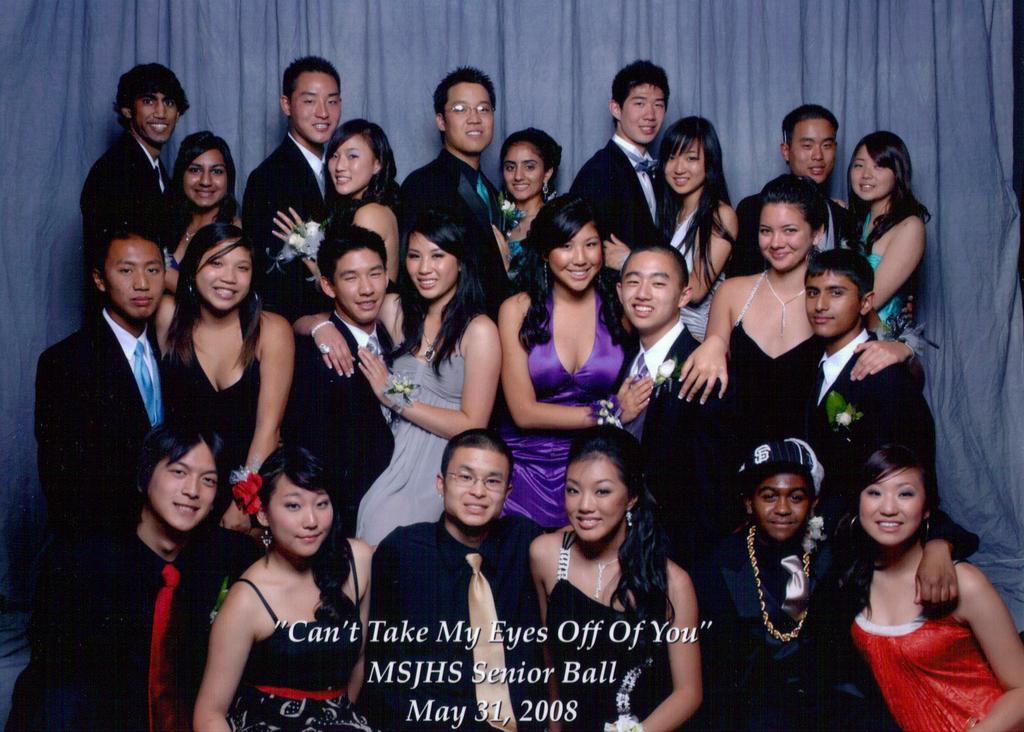Can you describe this image briefly? In this image I can see a group of people and they are wearing different color dresses. Back I can see a blue curtain and something is written on it. 